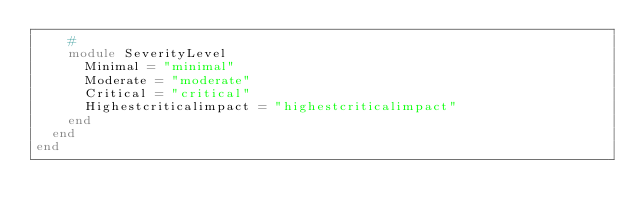<code> <loc_0><loc_0><loc_500><loc_500><_Ruby_>    #
    module SeverityLevel
      Minimal = "minimal"
      Moderate = "moderate"
      Critical = "critical"
      Highestcriticalimpact = "highestcriticalimpact"
    end
  end
end
</code> 